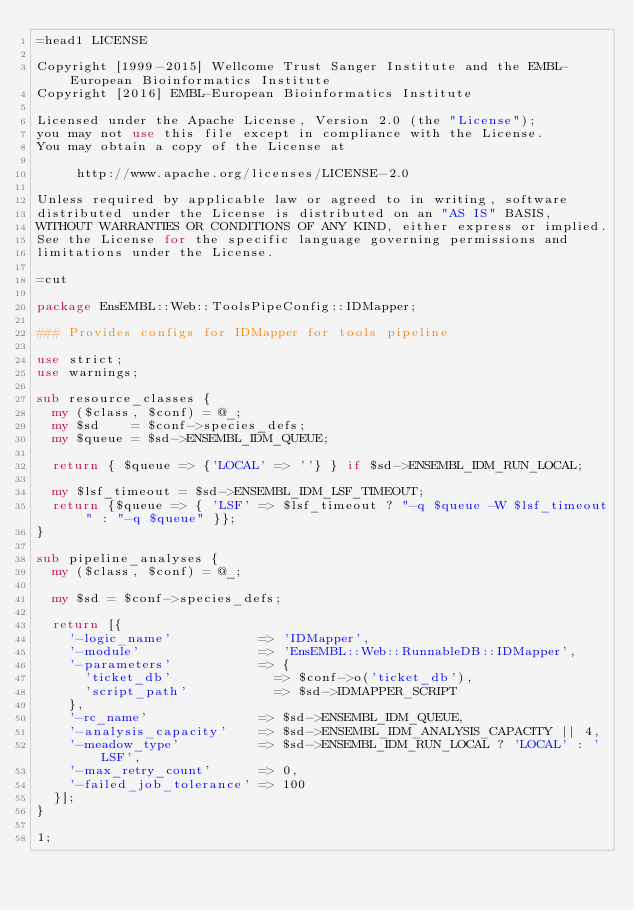<code> <loc_0><loc_0><loc_500><loc_500><_Perl_>=head1 LICENSE

Copyright [1999-2015] Wellcome Trust Sanger Institute and the EMBL-European Bioinformatics Institute
Copyright [2016] EMBL-European Bioinformatics Institute

Licensed under the Apache License, Version 2.0 (the "License");
you may not use this file except in compliance with the License.
You may obtain a copy of the License at

     http://www.apache.org/licenses/LICENSE-2.0

Unless required by applicable law or agreed to in writing, software
distributed under the License is distributed on an "AS IS" BASIS,
WITHOUT WARRANTIES OR CONDITIONS OF ANY KIND, either express or implied.
See the License for the specific language governing permissions and
limitations under the License.

=cut

package EnsEMBL::Web::ToolsPipeConfig::IDMapper;

### Provides configs for IDMapper for tools pipeline

use strict;
use warnings;

sub resource_classes {
  my ($class, $conf) = @_;
  my $sd    = $conf->species_defs;
  my $queue = $sd->ENSEMBL_IDM_QUEUE;

  return { $queue => {'LOCAL' => ''} } if $sd->ENSEMBL_IDM_RUN_LOCAL;

  my $lsf_timeout = $sd->ENSEMBL_IDM_LSF_TIMEOUT;
  return {$queue => { 'LSF' => $lsf_timeout ? "-q $queue -W $lsf_timeout" : "-q $queue" }};
}

sub pipeline_analyses {
  my ($class, $conf) = @_;

  my $sd = $conf->species_defs;

  return [{
    '-logic_name'           => 'IDMapper',
    '-module'               => 'EnsEMBL::Web::RunnableDB::IDMapper',
    '-parameters'           => {
      'ticket_db'             => $conf->o('ticket_db'),
      'script_path'           => $sd->IDMAPPER_SCRIPT
    },
    '-rc_name'              => $sd->ENSEMBL_IDM_QUEUE,
    '-analysis_capacity'    => $sd->ENSEMBL_IDM_ANALYSIS_CAPACITY || 4,
    '-meadow_type'          => $sd->ENSEMBL_IDM_RUN_LOCAL ? 'LOCAL' : 'LSF',
    '-max_retry_count'      => 0,
    '-failed_job_tolerance' => 100
  }];
}

1;
</code> 